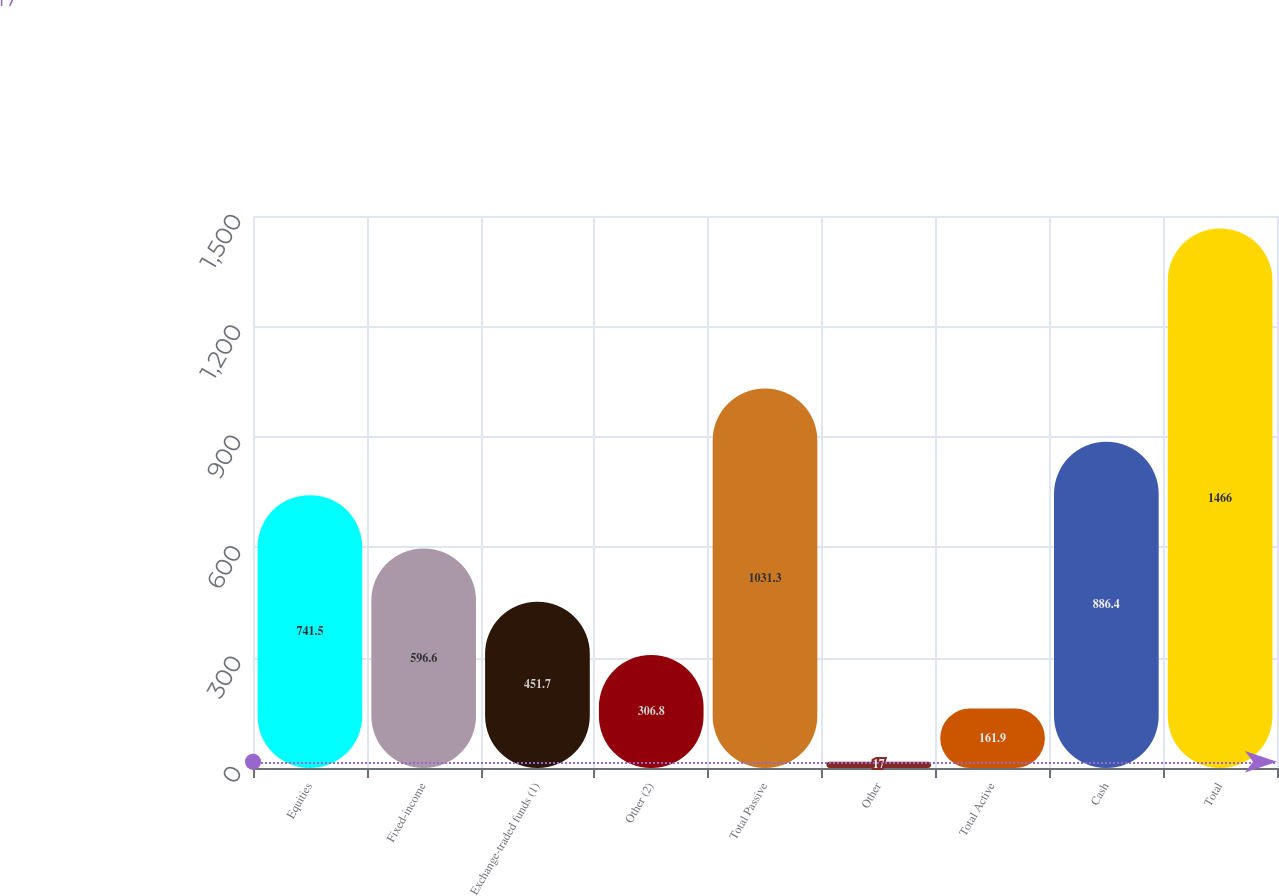Convert chart. <chart><loc_0><loc_0><loc_500><loc_500><bar_chart><fcel>Equities<fcel>Fixed-income<fcel>Exchange-traded funds (1)<fcel>Other (2)<fcel>Total Passive<fcel>Other<fcel>Total Active<fcel>Cash<fcel>Total<nl><fcel>741.5<fcel>596.6<fcel>451.7<fcel>306.8<fcel>1031.3<fcel>17<fcel>161.9<fcel>886.4<fcel>1466<nl></chart> 